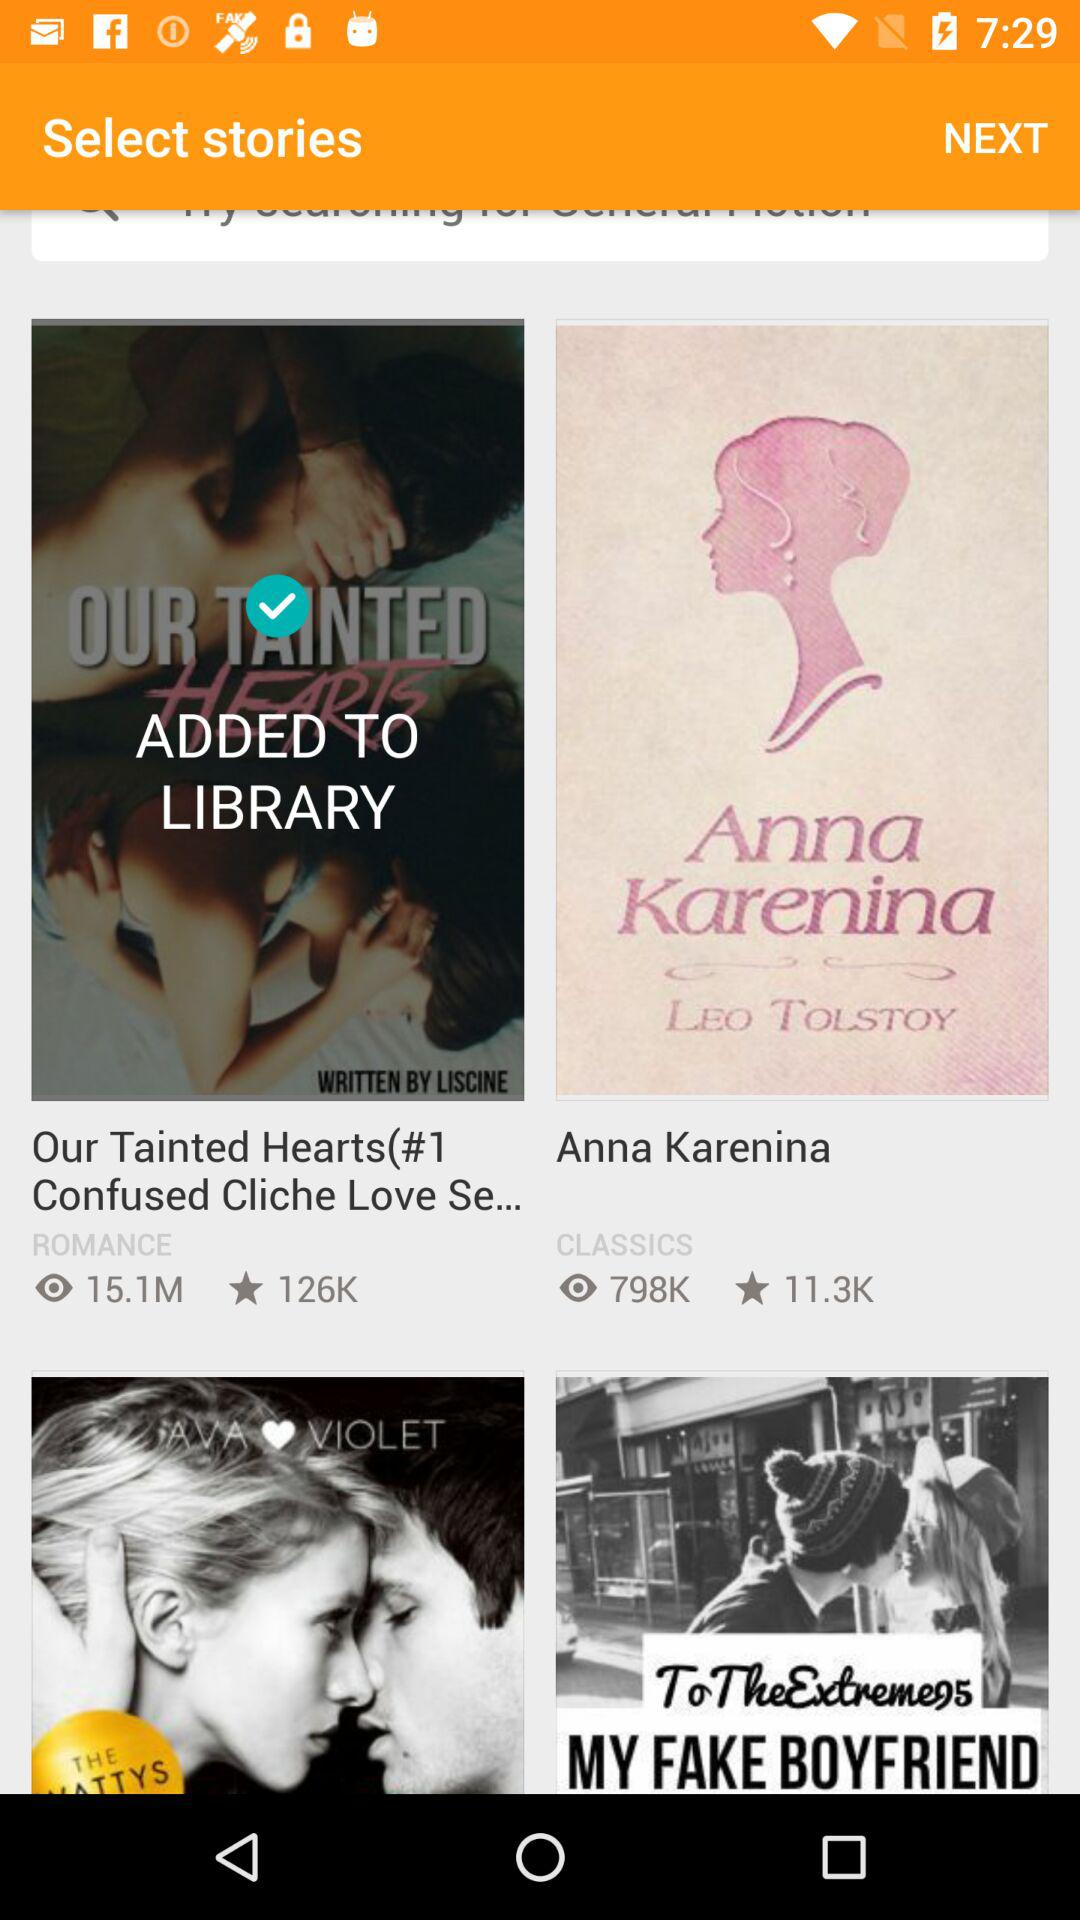What is the number of views of the "Anna Karenina" story? The number of views is 798K. 